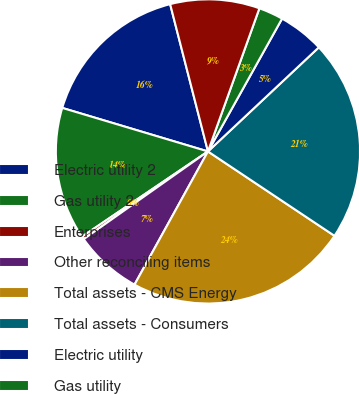<chart> <loc_0><loc_0><loc_500><loc_500><pie_chart><fcel>Electric utility 2<fcel>Gas utility 2<fcel>Enterprises<fcel>Other reconciling items<fcel>Total assets - CMS Energy<fcel>Total assets - Consumers<fcel>Electric utility<fcel>Gas utility<fcel>Total capital expenditures -<nl><fcel>16.38%<fcel>14.09%<fcel>0.31%<fcel>7.2%<fcel>23.66%<fcel>21.36%<fcel>4.9%<fcel>2.61%<fcel>9.49%<nl></chart> 